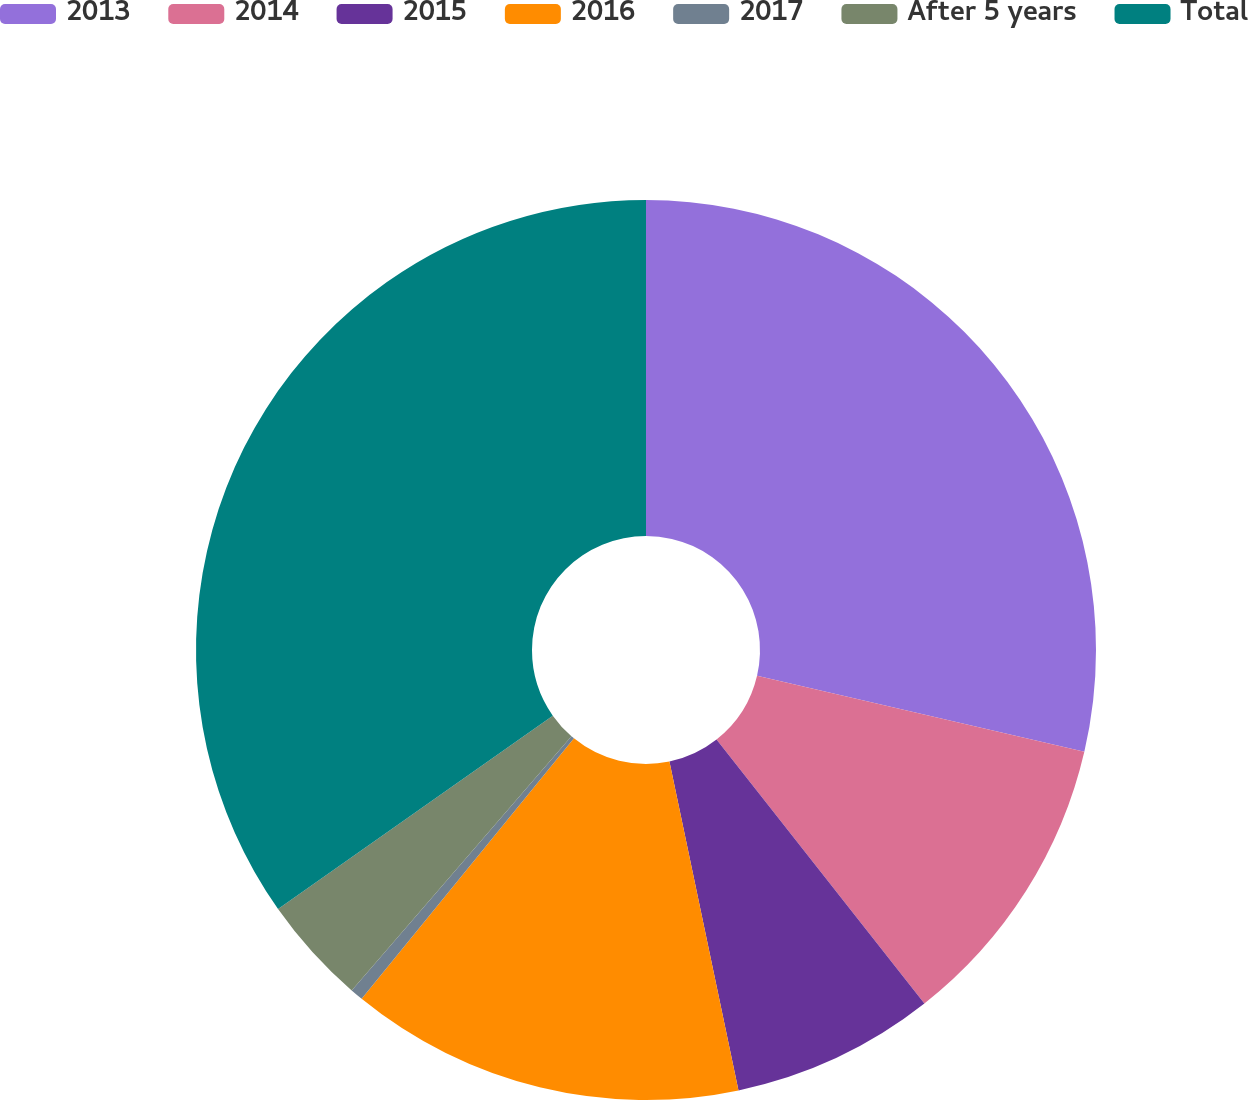<chart> <loc_0><loc_0><loc_500><loc_500><pie_chart><fcel>2013<fcel>2014<fcel>2015<fcel>2016<fcel>2017<fcel>After 5 years<fcel>Total<nl><fcel>28.63%<fcel>10.75%<fcel>7.32%<fcel>14.18%<fcel>0.46%<fcel>3.89%<fcel>34.76%<nl></chart> 